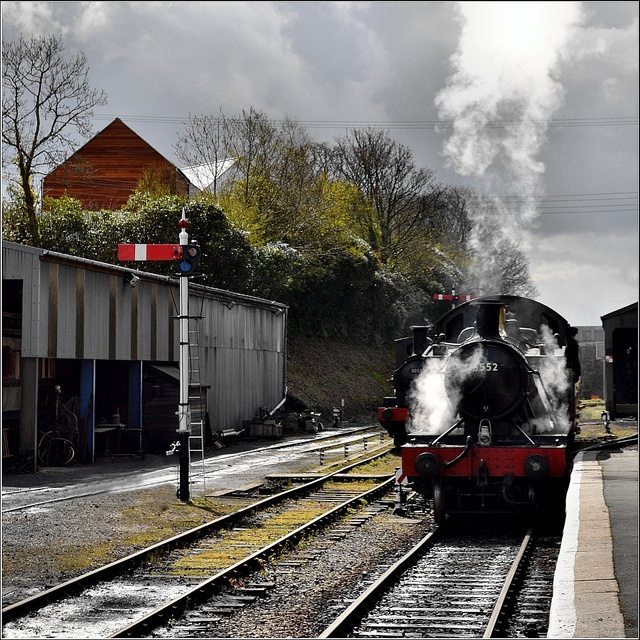Describe the objects in this image and their specific colors. I can see train in black, gray, darkgray, and lightgray tones, traffic light in black, navy, gray, and darkblue tones, and traffic light in black, maroon, salmon, and brown tones in this image. 